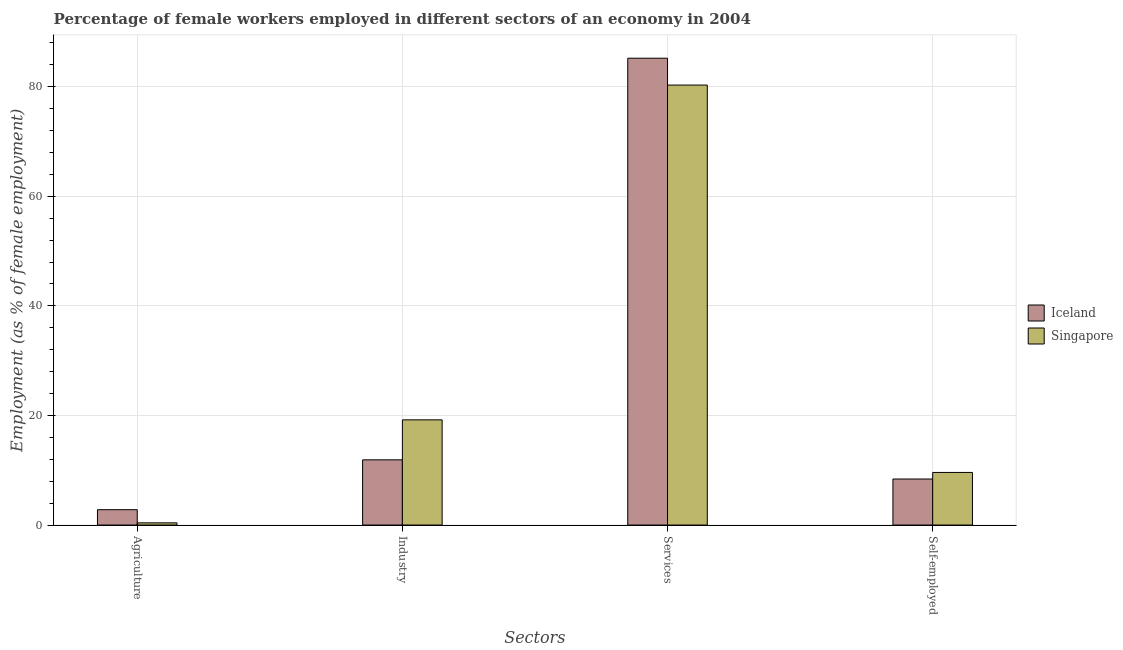How many different coloured bars are there?
Your answer should be compact. 2. Are the number of bars per tick equal to the number of legend labels?
Make the answer very short. Yes. Are the number of bars on each tick of the X-axis equal?
Your answer should be very brief. Yes. How many bars are there on the 2nd tick from the left?
Offer a terse response. 2. What is the label of the 1st group of bars from the left?
Provide a short and direct response. Agriculture. What is the percentage of female workers in industry in Iceland?
Ensure brevity in your answer.  11.9. Across all countries, what is the maximum percentage of female workers in industry?
Your answer should be compact. 19.2. Across all countries, what is the minimum percentage of self employed female workers?
Your answer should be very brief. 8.4. In which country was the percentage of female workers in services maximum?
Offer a terse response. Iceland. In which country was the percentage of female workers in industry minimum?
Give a very brief answer. Iceland. What is the total percentage of female workers in services in the graph?
Keep it short and to the point. 165.5. What is the difference between the percentage of self employed female workers in Iceland and that in Singapore?
Your answer should be compact. -1.2. What is the difference between the percentage of female workers in industry in Iceland and the percentage of self employed female workers in Singapore?
Your response must be concise. 2.3. What is the average percentage of self employed female workers per country?
Offer a very short reply. 9. What is the difference between the percentage of self employed female workers and percentage of female workers in services in Singapore?
Your response must be concise. -70.7. What is the ratio of the percentage of self employed female workers in Iceland to that in Singapore?
Offer a very short reply. 0.87. Is the percentage of female workers in services in Singapore less than that in Iceland?
Give a very brief answer. Yes. What is the difference between the highest and the second highest percentage of female workers in services?
Provide a succinct answer. 4.9. What is the difference between the highest and the lowest percentage of female workers in industry?
Give a very brief answer. 7.3. Is the sum of the percentage of self employed female workers in Singapore and Iceland greater than the maximum percentage of female workers in industry across all countries?
Your answer should be very brief. No. What does the 2nd bar from the left in Industry represents?
Your response must be concise. Singapore. What does the 1st bar from the right in Agriculture represents?
Make the answer very short. Singapore. How many bars are there?
Make the answer very short. 8. Are all the bars in the graph horizontal?
Your answer should be very brief. No. What is the difference between two consecutive major ticks on the Y-axis?
Keep it short and to the point. 20. Are the values on the major ticks of Y-axis written in scientific E-notation?
Keep it short and to the point. No. Does the graph contain any zero values?
Offer a very short reply. No. Does the graph contain grids?
Your answer should be compact. Yes. How are the legend labels stacked?
Ensure brevity in your answer.  Vertical. What is the title of the graph?
Give a very brief answer. Percentage of female workers employed in different sectors of an economy in 2004. Does "Latin America(all income levels)" appear as one of the legend labels in the graph?
Give a very brief answer. No. What is the label or title of the X-axis?
Your answer should be very brief. Sectors. What is the label or title of the Y-axis?
Provide a succinct answer. Employment (as % of female employment). What is the Employment (as % of female employment) in Iceland in Agriculture?
Give a very brief answer. 2.8. What is the Employment (as % of female employment) of Singapore in Agriculture?
Your answer should be very brief. 0.4. What is the Employment (as % of female employment) in Iceland in Industry?
Your answer should be very brief. 11.9. What is the Employment (as % of female employment) in Singapore in Industry?
Provide a succinct answer. 19.2. What is the Employment (as % of female employment) of Iceland in Services?
Keep it short and to the point. 85.2. What is the Employment (as % of female employment) of Singapore in Services?
Your answer should be compact. 80.3. What is the Employment (as % of female employment) in Iceland in Self-employed?
Your answer should be very brief. 8.4. What is the Employment (as % of female employment) in Singapore in Self-employed?
Offer a terse response. 9.6. Across all Sectors, what is the maximum Employment (as % of female employment) of Iceland?
Your answer should be compact. 85.2. Across all Sectors, what is the maximum Employment (as % of female employment) of Singapore?
Make the answer very short. 80.3. Across all Sectors, what is the minimum Employment (as % of female employment) of Iceland?
Offer a very short reply. 2.8. Across all Sectors, what is the minimum Employment (as % of female employment) in Singapore?
Provide a short and direct response. 0.4. What is the total Employment (as % of female employment) of Iceland in the graph?
Keep it short and to the point. 108.3. What is the total Employment (as % of female employment) in Singapore in the graph?
Offer a very short reply. 109.5. What is the difference between the Employment (as % of female employment) in Singapore in Agriculture and that in Industry?
Offer a terse response. -18.8. What is the difference between the Employment (as % of female employment) in Iceland in Agriculture and that in Services?
Keep it short and to the point. -82.4. What is the difference between the Employment (as % of female employment) in Singapore in Agriculture and that in Services?
Offer a terse response. -79.9. What is the difference between the Employment (as % of female employment) of Singapore in Agriculture and that in Self-employed?
Your answer should be compact. -9.2. What is the difference between the Employment (as % of female employment) in Iceland in Industry and that in Services?
Make the answer very short. -73.3. What is the difference between the Employment (as % of female employment) of Singapore in Industry and that in Services?
Your answer should be compact. -61.1. What is the difference between the Employment (as % of female employment) of Iceland in Industry and that in Self-employed?
Offer a terse response. 3.5. What is the difference between the Employment (as % of female employment) of Singapore in Industry and that in Self-employed?
Your response must be concise. 9.6. What is the difference between the Employment (as % of female employment) in Iceland in Services and that in Self-employed?
Your response must be concise. 76.8. What is the difference between the Employment (as % of female employment) in Singapore in Services and that in Self-employed?
Your answer should be compact. 70.7. What is the difference between the Employment (as % of female employment) in Iceland in Agriculture and the Employment (as % of female employment) in Singapore in Industry?
Your answer should be very brief. -16.4. What is the difference between the Employment (as % of female employment) in Iceland in Agriculture and the Employment (as % of female employment) in Singapore in Services?
Make the answer very short. -77.5. What is the difference between the Employment (as % of female employment) of Iceland in Industry and the Employment (as % of female employment) of Singapore in Services?
Provide a short and direct response. -68.4. What is the difference between the Employment (as % of female employment) in Iceland in Services and the Employment (as % of female employment) in Singapore in Self-employed?
Make the answer very short. 75.6. What is the average Employment (as % of female employment) of Iceland per Sectors?
Offer a very short reply. 27.07. What is the average Employment (as % of female employment) of Singapore per Sectors?
Your response must be concise. 27.38. What is the ratio of the Employment (as % of female employment) of Iceland in Agriculture to that in Industry?
Offer a very short reply. 0.24. What is the ratio of the Employment (as % of female employment) in Singapore in Agriculture to that in Industry?
Ensure brevity in your answer.  0.02. What is the ratio of the Employment (as % of female employment) of Iceland in Agriculture to that in Services?
Provide a succinct answer. 0.03. What is the ratio of the Employment (as % of female employment) in Singapore in Agriculture to that in Services?
Keep it short and to the point. 0.01. What is the ratio of the Employment (as % of female employment) in Singapore in Agriculture to that in Self-employed?
Provide a succinct answer. 0.04. What is the ratio of the Employment (as % of female employment) in Iceland in Industry to that in Services?
Ensure brevity in your answer.  0.14. What is the ratio of the Employment (as % of female employment) of Singapore in Industry to that in Services?
Make the answer very short. 0.24. What is the ratio of the Employment (as % of female employment) of Iceland in Industry to that in Self-employed?
Offer a terse response. 1.42. What is the ratio of the Employment (as % of female employment) in Singapore in Industry to that in Self-employed?
Ensure brevity in your answer.  2. What is the ratio of the Employment (as % of female employment) in Iceland in Services to that in Self-employed?
Offer a terse response. 10.14. What is the ratio of the Employment (as % of female employment) of Singapore in Services to that in Self-employed?
Keep it short and to the point. 8.36. What is the difference between the highest and the second highest Employment (as % of female employment) of Iceland?
Offer a very short reply. 73.3. What is the difference between the highest and the second highest Employment (as % of female employment) in Singapore?
Your answer should be very brief. 61.1. What is the difference between the highest and the lowest Employment (as % of female employment) of Iceland?
Provide a short and direct response. 82.4. What is the difference between the highest and the lowest Employment (as % of female employment) in Singapore?
Keep it short and to the point. 79.9. 